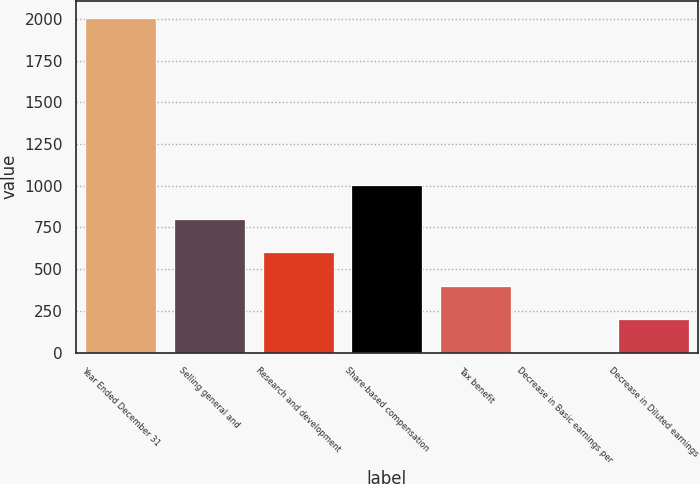<chart> <loc_0><loc_0><loc_500><loc_500><bar_chart><fcel>Year Ended December 31<fcel>Selling general and<fcel>Research and development<fcel>Share-based compensation<fcel>Tax benefit<fcel>Decrease in Basic earnings per<fcel>Decrease in Diluted earnings<nl><fcel>2007<fcel>802.84<fcel>602.15<fcel>1003.53<fcel>401.46<fcel>0.08<fcel>200.77<nl></chart> 